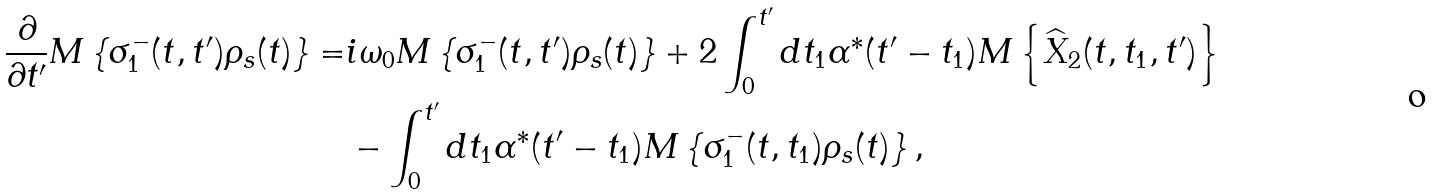Convert formula to latex. <formula><loc_0><loc_0><loc_500><loc_500>\frac { \partial } { \partial t ^ { \prime } } M \left \{ \sigma _ { 1 } ^ { - } ( t , t ^ { \prime } ) \rho _ { s } ( t ) \right \} = & i \omega _ { 0 } M \left \{ \sigma _ { 1 } ^ { - } ( t , t ^ { \prime } ) \rho _ { s } ( t ) \right \} + 2 \int _ { 0 } ^ { t ^ { \prime } } d t _ { 1 } \alpha ^ { * } ( t ^ { \prime } - t _ { 1 } ) M \left \{ \widehat { X } _ { 2 } ( t , t _ { 1 } , t ^ { \prime } ) \right \} \\ & - \int _ { 0 } ^ { t ^ { \prime } } d t _ { 1 } \alpha ^ { * } ( t ^ { \prime } - t _ { 1 } ) M \left \{ \sigma _ { 1 } ^ { - } ( t , t _ { 1 } ) \rho _ { s } ( t ) \right \} ,</formula> 